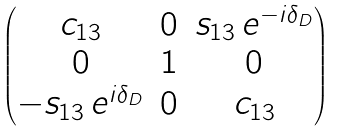<formula> <loc_0><loc_0><loc_500><loc_500>\begin{pmatrix} c _ { 1 3 } & 0 & s _ { 1 3 } \, e ^ { - i \delta _ { D } } \\ 0 & 1 & 0 \\ - s _ { 1 3 } \, e ^ { i \delta _ { D } } & 0 & c _ { 1 3 } \end{pmatrix}</formula> 